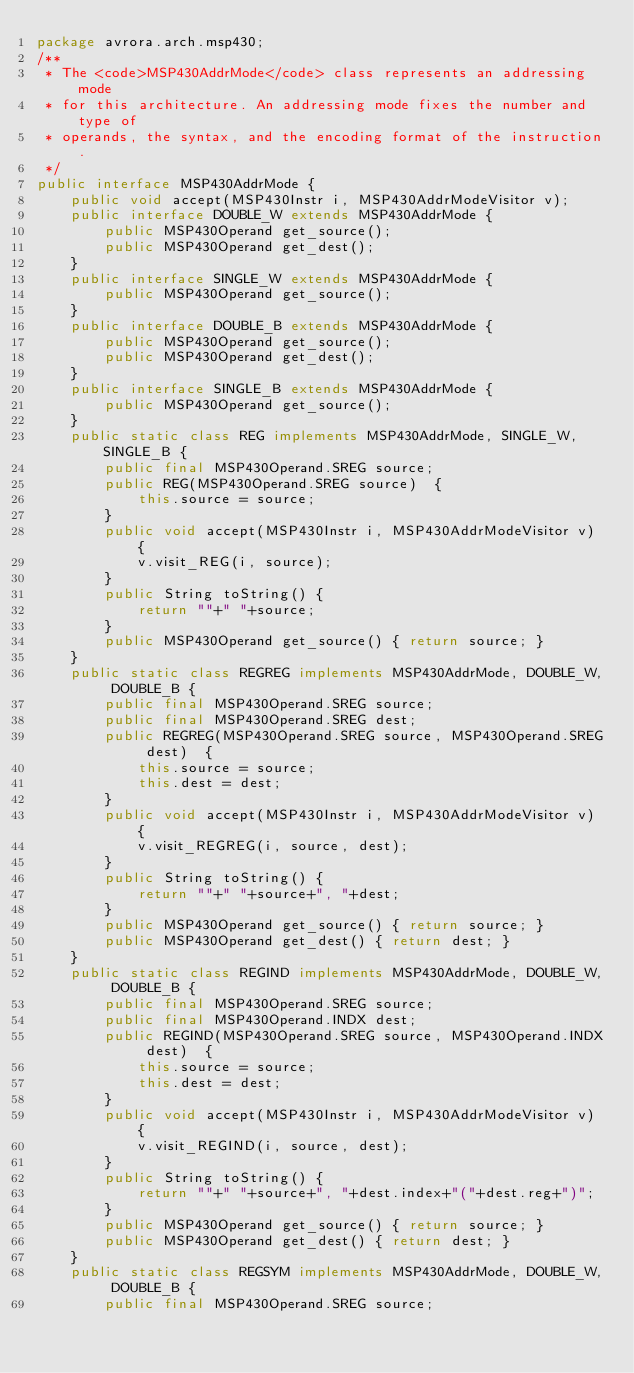Convert code to text. <code><loc_0><loc_0><loc_500><loc_500><_Java_>package avrora.arch.msp430;
/**
 * The <code>MSP430AddrMode</code> class represents an addressing mode
 * for this architecture. An addressing mode fixes the number and type of
 * operands, the syntax, and the encoding format of the instruction.
 */
public interface MSP430AddrMode {
    public void accept(MSP430Instr i, MSP430AddrModeVisitor v);
    public interface DOUBLE_W extends MSP430AddrMode {
        public MSP430Operand get_source();
        public MSP430Operand get_dest();
    }
    public interface SINGLE_W extends MSP430AddrMode {
        public MSP430Operand get_source();
    }
    public interface DOUBLE_B extends MSP430AddrMode {
        public MSP430Operand get_source();
        public MSP430Operand get_dest();
    }
    public interface SINGLE_B extends MSP430AddrMode {
        public MSP430Operand get_source();
    }
    public static class REG implements MSP430AddrMode, SINGLE_W, SINGLE_B {
        public final MSP430Operand.SREG source;
        public REG(MSP430Operand.SREG source)  {
            this.source = source;
        }
        public void accept(MSP430Instr i, MSP430AddrModeVisitor v) {
            v.visit_REG(i, source);
        }
        public String toString() {
            return ""+" "+source;
        }
        public MSP430Operand get_source() { return source; }
    }
    public static class REGREG implements MSP430AddrMode, DOUBLE_W, DOUBLE_B {
        public final MSP430Operand.SREG source;
        public final MSP430Operand.SREG dest;
        public REGREG(MSP430Operand.SREG source, MSP430Operand.SREG dest)  {
            this.source = source;
            this.dest = dest;
        }
        public void accept(MSP430Instr i, MSP430AddrModeVisitor v) {
            v.visit_REGREG(i, source, dest);
        }
        public String toString() {
            return ""+" "+source+", "+dest;
        }
        public MSP430Operand get_source() { return source; }
        public MSP430Operand get_dest() { return dest; }
    }
    public static class REGIND implements MSP430AddrMode, DOUBLE_W, DOUBLE_B {
        public final MSP430Operand.SREG source;
        public final MSP430Operand.INDX dest;
        public REGIND(MSP430Operand.SREG source, MSP430Operand.INDX dest)  {
            this.source = source;
            this.dest = dest;
        }
        public void accept(MSP430Instr i, MSP430AddrModeVisitor v) {
            v.visit_REGIND(i, source, dest);
        }
        public String toString() {
            return ""+" "+source+", "+dest.index+"("+dest.reg+")";
        }
        public MSP430Operand get_source() { return source; }
        public MSP430Operand get_dest() { return dest; }
    }
    public static class REGSYM implements MSP430AddrMode, DOUBLE_W, DOUBLE_B {
        public final MSP430Operand.SREG source;</code> 